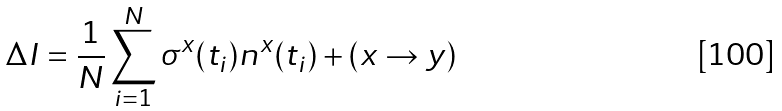Convert formula to latex. <formula><loc_0><loc_0><loc_500><loc_500>\Delta I = \frac { 1 } { N } \sum _ { i = 1 } ^ { N } \sigma ^ { x } ( t _ { i } ) n ^ { x } ( t _ { i } ) + ( x \rightarrow y )</formula> 